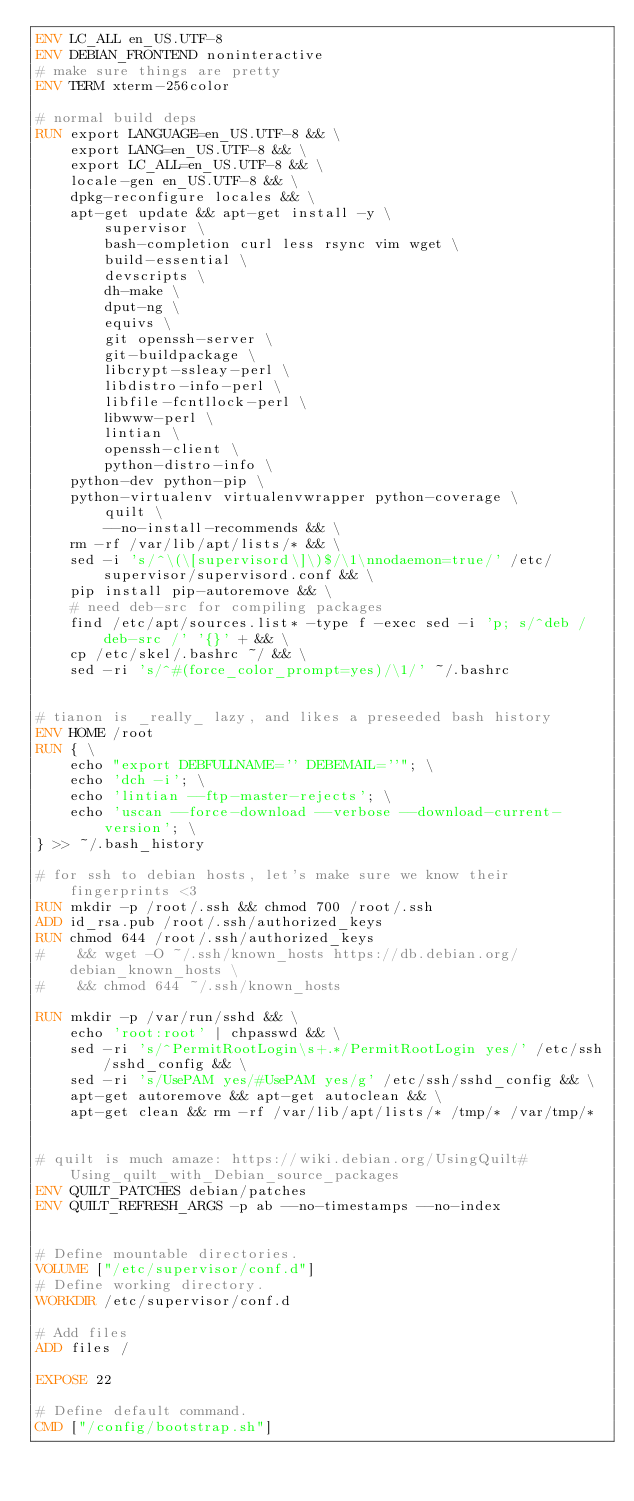<code> <loc_0><loc_0><loc_500><loc_500><_Dockerfile_>ENV LC_ALL en_US.UTF-8
ENV DEBIAN_FRONTEND noninteractive
# make sure things are pretty
ENV TERM xterm-256color

# normal build deps
RUN export LANGUAGE=en_US.UTF-8 && \
    export LANG=en_US.UTF-8 && \
    export LC_ALL=en_US.UTF-8 && \
    locale-gen en_US.UTF-8 && \
    dpkg-reconfigure locales && \
    apt-get update && apt-get install -y \
        supervisor \
        bash-completion curl less rsync vim wget \
        build-essential \
        devscripts \
        dh-make \
        dput-ng \
        equivs \
        git openssh-server \
        git-buildpackage \
        libcrypt-ssleay-perl \
        libdistro-info-perl \
        libfile-fcntllock-perl \
        libwww-perl \
        lintian \
        openssh-client \
        python-distro-info \
	python-dev python-pip \
	python-virtualenv virtualenvwrapper python-coverage \
        quilt \
        --no-install-recommends && \
    rm -rf /var/lib/apt/lists/* && \
    sed -i 's/^\(\[supervisord\]\)$/\1\nnodaemon=true/' /etc/supervisor/supervisord.conf && \
    pip install pip-autoremove && \
    # need deb-src for compiling packages
    find /etc/apt/sources.list* -type f -exec sed -i 'p; s/^deb /deb-src /' '{}' + && \
    cp /etc/skel/.bashrc ~/ && \
    sed -ri 's/^#(force_color_prompt=yes)/\1/' ~/.bashrc


# tianon is _really_ lazy, and likes a preseeded bash history
ENV HOME /root
RUN { \
    echo "export DEBFULLNAME='' DEBEMAIL=''"; \
    echo 'dch -i'; \
    echo 'lintian --ftp-master-rejects'; \
    echo 'uscan --force-download --verbose --download-current-version'; \
} >> ~/.bash_history

# for ssh to debian hosts, let's make sure we know their fingerprints <3
RUN mkdir -p /root/.ssh && chmod 700 /root/.ssh 
ADD id_rsa.pub /root/.ssh/authorized_keys
RUN chmod 644 /root/.ssh/authorized_keys
#    && wget -O ~/.ssh/known_hosts https://db.debian.org/debian_known_hosts \
#    && chmod 644 ~/.ssh/known_hosts

RUN mkdir -p /var/run/sshd && \
    echo 'root:root' | chpasswd && \
    sed -ri 's/^PermitRootLogin\s+.*/PermitRootLogin yes/' /etc/ssh/sshd_config && \
    sed -ri 's/UsePAM yes/#UsePAM yes/g' /etc/ssh/sshd_config && \
    apt-get autoremove && apt-get autoclean && \
    apt-get clean && rm -rf /var/lib/apt/lists/* /tmp/* /var/tmp/*


# quilt is much amaze: https://wiki.debian.org/UsingQuilt#Using_quilt_with_Debian_source_packages
ENV QUILT_PATCHES debian/patches
ENV QUILT_REFRESH_ARGS -p ab --no-timestamps --no-index


# Define mountable directories.
VOLUME ["/etc/supervisor/conf.d"]
# Define working directory.
WORKDIR /etc/supervisor/conf.d

# Add files
ADD files /

EXPOSE 22

# Define default command.
CMD ["/config/bootstrap.sh"]

</code> 